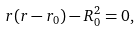<formula> <loc_0><loc_0><loc_500><loc_500>r ( r - r _ { 0 } ) - R _ { 0 } ^ { 2 } = 0 ,</formula> 